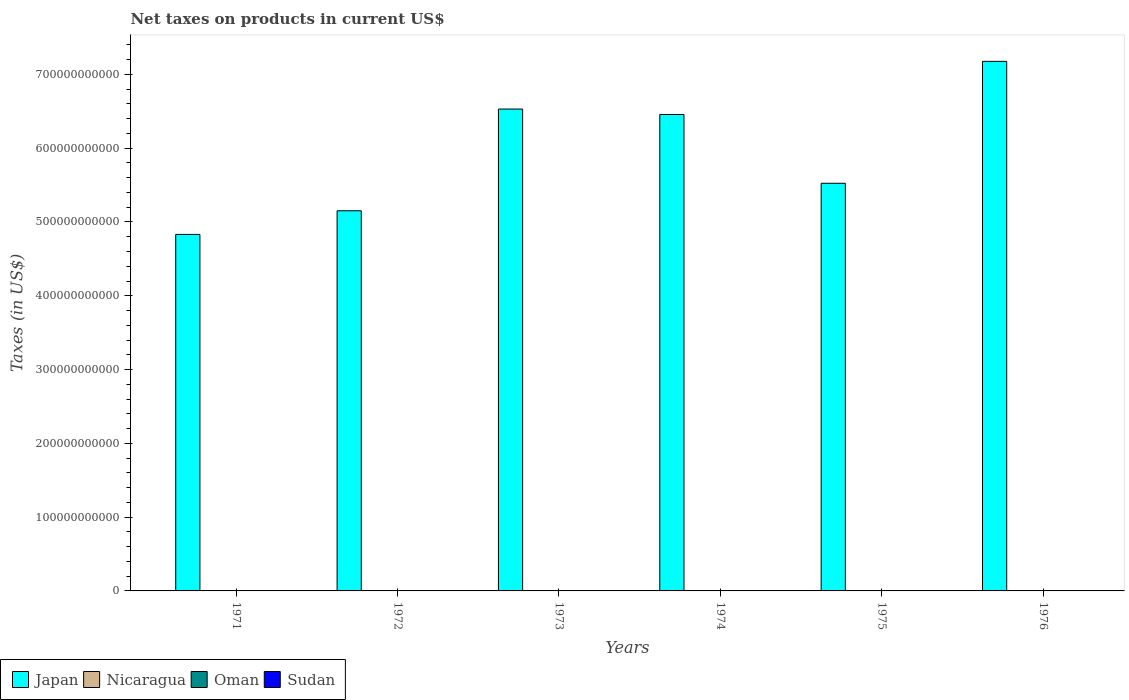How many groups of bars are there?
Provide a short and direct response. 6. Are the number of bars per tick equal to the number of legend labels?
Your answer should be very brief. Yes. How many bars are there on the 6th tick from the left?
Offer a very short reply. 4. How many bars are there on the 6th tick from the right?
Ensure brevity in your answer.  4. What is the label of the 4th group of bars from the left?
Offer a very short reply. 1974. In how many cases, is the number of bars for a given year not equal to the number of legend labels?
Your answer should be compact. 0. What is the net taxes on products in Nicaragua in 1975?
Provide a short and direct response. 0.17. Across all years, what is the maximum net taxes on products in Oman?
Your answer should be very brief. 4.50e+06. Across all years, what is the minimum net taxes on products in Oman?
Your response must be concise. 5.00e+05. In which year was the net taxes on products in Oman maximum?
Offer a very short reply. 1976. What is the total net taxes on products in Japan in the graph?
Provide a short and direct response. 3.57e+12. What is the difference between the net taxes on products in Nicaragua in 1972 and that in 1976?
Your response must be concise. -0.17. What is the difference between the net taxes on products in Sudan in 1975 and the net taxes on products in Nicaragua in 1974?
Your answer should be compact. 1.97e+05. What is the average net taxes on products in Sudan per year?
Make the answer very short. 1.54e+05. In the year 1971, what is the difference between the net taxes on products in Oman and net taxes on products in Nicaragua?
Provide a succinct answer. 1.10e+06. In how many years, is the net taxes on products in Oman greater than 100000000000 US$?
Make the answer very short. 0. What is the ratio of the net taxes on products in Oman in 1972 to that in 1974?
Keep it short and to the point. 0.7. Is the net taxes on products in Oman in 1973 less than that in 1976?
Give a very brief answer. Yes. Is the difference between the net taxes on products in Oman in 1971 and 1975 greater than the difference between the net taxes on products in Nicaragua in 1971 and 1975?
Offer a terse response. Yes. What is the difference between the highest and the second highest net taxes on products in Nicaragua?
Keep it short and to the point. 0.09. What is the difference between the highest and the lowest net taxes on products in Nicaragua?
Make the answer very short. 0.19. Is the sum of the net taxes on products in Japan in 1972 and 1975 greater than the maximum net taxes on products in Oman across all years?
Keep it short and to the point. Yes. Is it the case that in every year, the sum of the net taxes on products in Sudan and net taxes on products in Nicaragua is greater than the sum of net taxes on products in Oman and net taxes on products in Japan?
Offer a very short reply. Yes. What does the 3rd bar from the left in 1973 represents?
Your answer should be very brief. Oman. What does the 2nd bar from the right in 1975 represents?
Make the answer very short. Oman. How many years are there in the graph?
Provide a short and direct response. 6. What is the difference between two consecutive major ticks on the Y-axis?
Keep it short and to the point. 1.00e+11. Where does the legend appear in the graph?
Your response must be concise. Bottom left. How many legend labels are there?
Offer a very short reply. 4. What is the title of the graph?
Provide a succinct answer. Net taxes on products in current US$. What is the label or title of the X-axis?
Make the answer very short. Years. What is the label or title of the Y-axis?
Your response must be concise. Taxes (in US$). What is the Taxes (in US$) of Japan in 1971?
Give a very brief answer. 4.83e+11. What is the Taxes (in US$) in Nicaragua in 1971?
Make the answer very short. 0.07. What is the Taxes (in US$) in Oman in 1971?
Keep it short and to the point. 1.10e+06. What is the Taxes (in US$) in Sudan in 1971?
Provide a short and direct response. 1.03e+05. What is the Taxes (in US$) of Japan in 1972?
Ensure brevity in your answer.  5.15e+11. What is the Taxes (in US$) in Nicaragua in 1972?
Offer a terse response. 0.09. What is the Taxes (in US$) in Oman in 1972?
Your answer should be compact. 1.60e+06. What is the Taxes (in US$) in Sudan in 1972?
Provide a succinct answer. 1.10e+05. What is the Taxes (in US$) of Japan in 1973?
Your answer should be compact. 6.53e+11. What is the Taxes (in US$) in Nicaragua in 1973?
Provide a succinct answer. 0.12. What is the Taxes (in US$) of Oman in 1973?
Your answer should be very brief. 1.70e+06. What is the Taxes (in US$) of Sudan in 1973?
Offer a very short reply. 1.20e+05. What is the Taxes (in US$) in Japan in 1974?
Keep it short and to the point. 6.46e+11. What is the Taxes (in US$) in Nicaragua in 1974?
Keep it short and to the point. 0.15. What is the Taxes (in US$) in Oman in 1974?
Ensure brevity in your answer.  2.30e+06. What is the Taxes (in US$) in Sudan in 1974?
Offer a very short reply. 1.50e+05. What is the Taxes (in US$) in Japan in 1975?
Ensure brevity in your answer.  5.52e+11. What is the Taxes (in US$) in Nicaragua in 1975?
Your response must be concise. 0.17. What is the Taxes (in US$) of Sudan in 1975?
Provide a short and direct response. 1.97e+05. What is the Taxes (in US$) of Japan in 1976?
Offer a terse response. 7.18e+11. What is the Taxes (in US$) of Nicaragua in 1976?
Provide a short and direct response. 0.26. What is the Taxes (in US$) of Oman in 1976?
Your response must be concise. 4.50e+06. What is the Taxes (in US$) of Sudan in 1976?
Provide a succinct answer. 2.41e+05. Across all years, what is the maximum Taxes (in US$) of Japan?
Provide a short and direct response. 7.18e+11. Across all years, what is the maximum Taxes (in US$) in Nicaragua?
Ensure brevity in your answer.  0.26. Across all years, what is the maximum Taxes (in US$) in Oman?
Provide a succinct answer. 4.50e+06. Across all years, what is the maximum Taxes (in US$) of Sudan?
Ensure brevity in your answer.  2.41e+05. Across all years, what is the minimum Taxes (in US$) in Japan?
Your response must be concise. 4.83e+11. Across all years, what is the minimum Taxes (in US$) of Nicaragua?
Your answer should be very brief. 0.07. Across all years, what is the minimum Taxes (in US$) of Sudan?
Your answer should be compact. 1.03e+05. What is the total Taxes (in US$) of Japan in the graph?
Make the answer very short. 3.57e+12. What is the total Taxes (in US$) in Nicaragua in the graph?
Make the answer very short. 0.86. What is the total Taxes (in US$) of Oman in the graph?
Your answer should be very brief. 1.17e+07. What is the total Taxes (in US$) of Sudan in the graph?
Your response must be concise. 9.21e+05. What is the difference between the Taxes (in US$) in Japan in 1971 and that in 1972?
Provide a succinct answer. -3.20e+1. What is the difference between the Taxes (in US$) in Nicaragua in 1971 and that in 1972?
Offer a very short reply. -0.03. What is the difference between the Taxes (in US$) in Oman in 1971 and that in 1972?
Provide a short and direct response. -5.00e+05. What is the difference between the Taxes (in US$) in Sudan in 1971 and that in 1972?
Your response must be concise. -7300. What is the difference between the Taxes (in US$) in Japan in 1971 and that in 1973?
Ensure brevity in your answer.  -1.70e+11. What is the difference between the Taxes (in US$) in Nicaragua in 1971 and that in 1973?
Offer a terse response. -0.06. What is the difference between the Taxes (in US$) of Oman in 1971 and that in 1973?
Make the answer very short. -6.00e+05. What is the difference between the Taxes (in US$) in Sudan in 1971 and that in 1973?
Keep it short and to the point. -1.75e+04. What is the difference between the Taxes (in US$) in Japan in 1971 and that in 1974?
Offer a terse response. -1.63e+11. What is the difference between the Taxes (in US$) of Nicaragua in 1971 and that in 1974?
Provide a short and direct response. -0.08. What is the difference between the Taxes (in US$) of Oman in 1971 and that in 1974?
Make the answer very short. -1.20e+06. What is the difference between the Taxes (in US$) in Sudan in 1971 and that in 1974?
Make the answer very short. -4.67e+04. What is the difference between the Taxes (in US$) of Japan in 1971 and that in 1975?
Keep it short and to the point. -6.93e+1. What is the difference between the Taxes (in US$) of Nicaragua in 1971 and that in 1975?
Your answer should be compact. -0.1. What is the difference between the Taxes (in US$) of Oman in 1971 and that in 1975?
Offer a very short reply. 6.00e+05. What is the difference between the Taxes (in US$) in Sudan in 1971 and that in 1975?
Make the answer very short. -9.43e+04. What is the difference between the Taxes (in US$) of Japan in 1971 and that in 1976?
Ensure brevity in your answer.  -2.35e+11. What is the difference between the Taxes (in US$) in Nicaragua in 1971 and that in 1976?
Keep it short and to the point. -0.19. What is the difference between the Taxes (in US$) of Oman in 1971 and that in 1976?
Ensure brevity in your answer.  -3.40e+06. What is the difference between the Taxes (in US$) in Sudan in 1971 and that in 1976?
Offer a very short reply. -1.38e+05. What is the difference between the Taxes (in US$) in Japan in 1972 and that in 1973?
Offer a very short reply. -1.38e+11. What is the difference between the Taxes (in US$) in Nicaragua in 1972 and that in 1973?
Provide a succinct answer. -0.03. What is the difference between the Taxes (in US$) of Sudan in 1972 and that in 1973?
Your response must be concise. -1.02e+04. What is the difference between the Taxes (in US$) in Japan in 1972 and that in 1974?
Offer a terse response. -1.30e+11. What is the difference between the Taxes (in US$) in Nicaragua in 1972 and that in 1974?
Your response must be concise. -0.06. What is the difference between the Taxes (in US$) of Oman in 1972 and that in 1974?
Give a very brief answer. -7.00e+05. What is the difference between the Taxes (in US$) of Sudan in 1972 and that in 1974?
Your answer should be compact. -3.94e+04. What is the difference between the Taxes (in US$) of Japan in 1972 and that in 1975?
Make the answer very short. -3.73e+1. What is the difference between the Taxes (in US$) in Nicaragua in 1972 and that in 1975?
Offer a terse response. -0.07. What is the difference between the Taxes (in US$) of Oman in 1972 and that in 1975?
Your answer should be very brief. 1.10e+06. What is the difference between the Taxes (in US$) in Sudan in 1972 and that in 1975?
Make the answer very short. -8.70e+04. What is the difference between the Taxes (in US$) of Japan in 1972 and that in 1976?
Keep it short and to the point. -2.02e+11. What is the difference between the Taxes (in US$) of Nicaragua in 1972 and that in 1976?
Your answer should be very brief. -0.17. What is the difference between the Taxes (in US$) of Oman in 1972 and that in 1976?
Offer a terse response. -2.90e+06. What is the difference between the Taxes (in US$) in Sudan in 1972 and that in 1976?
Give a very brief answer. -1.30e+05. What is the difference between the Taxes (in US$) of Japan in 1973 and that in 1974?
Offer a very short reply. 7.37e+09. What is the difference between the Taxes (in US$) in Nicaragua in 1973 and that in 1974?
Your answer should be very brief. -0.03. What is the difference between the Taxes (in US$) in Oman in 1973 and that in 1974?
Give a very brief answer. -6.00e+05. What is the difference between the Taxes (in US$) of Sudan in 1973 and that in 1974?
Give a very brief answer. -2.92e+04. What is the difference between the Taxes (in US$) of Japan in 1973 and that in 1975?
Provide a short and direct response. 1.01e+11. What is the difference between the Taxes (in US$) in Nicaragua in 1973 and that in 1975?
Your answer should be compact. -0.05. What is the difference between the Taxes (in US$) in Oman in 1973 and that in 1975?
Your answer should be very brief. 1.20e+06. What is the difference between the Taxes (in US$) of Sudan in 1973 and that in 1975?
Provide a succinct answer. -7.68e+04. What is the difference between the Taxes (in US$) of Japan in 1973 and that in 1976?
Keep it short and to the point. -6.46e+1. What is the difference between the Taxes (in US$) of Nicaragua in 1973 and that in 1976?
Your response must be concise. -0.14. What is the difference between the Taxes (in US$) in Oman in 1973 and that in 1976?
Keep it short and to the point. -2.80e+06. What is the difference between the Taxes (in US$) of Sudan in 1973 and that in 1976?
Keep it short and to the point. -1.20e+05. What is the difference between the Taxes (in US$) of Japan in 1974 and that in 1975?
Offer a very short reply. 9.32e+1. What is the difference between the Taxes (in US$) of Nicaragua in 1974 and that in 1975?
Ensure brevity in your answer.  -0.02. What is the difference between the Taxes (in US$) of Oman in 1974 and that in 1975?
Give a very brief answer. 1.80e+06. What is the difference between the Taxes (in US$) in Sudan in 1974 and that in 1975?
Offer a very short reply. -4.76e+04. What is the difference between the Taxes (in US$) in Japan in 1974 and that in 1976?
Provide a short and direct response. -7.20e+1. What is the difference between the Taxes (in US$) of Nicaragua in 1974 and that in 1976?
Your answer should be very brief. -0.11. What is the difference between the Taxes (in US$) of Oman in 1974 and that in 1976?
Your answer should be compact. -2.20e+06. What is the difference between the Taxes (in US$) in Sudan in 1974 and that in 1976?
Offer a terse response. -9.11e+04. What is the difference between the Taxes (in US$) of Japan in 1975 and that in 1976?
Offer a very short reply. -1.65e+11. What is the difference between the Taxes (in US$) of Nicaragua in 1975 and that in 1976?
Your response must be concise. -0.09. What is the difference between the Taxes (in US$) of Sudan in 1975 and that in 1976?
Provide a short and direct response. -4.35e+04. What is the difference between the Taxes (in US$) in Japan in 1971 and the Taxes (in US$) in Nicaragua in 1972?
Offer a very short reply. 4.83e+11. What is the difference between the Taxes (in US$) in Japan in 1971 and the Taxes (in US$) in Oman in 1972?
Make the answer very short. 4.83e+11. What is the difference between the Taxes (in US$) in Japan in 1971 and the Taxes (in US$) in Sudan in 1972?
Give a very brief answer. 4.83e+11. What is the difference between the Taxes (in US$) in Nicaragua in 1971 and the Taxes (in US$) in Oman in 1972?
Provide a short and direct response. -1.60e+06. What is the difference between the Taxes (in US$) of Nicaragua in 1971 and the Taxes (in US$) of Sudan in 1972?
Your answer should be very brief. -1.10e+05. What is the difference between the Taxes (in US$) in Oman in 1971 and the Taxes (in US$) in Sudan in 1972?
Provide a short and direct response. 9.90e+05. What is the difference between the Taxes (in US$) in Japan in 1971 and the Taxes (in US$) in Nicaragua in 1973?
Give a very brief answer. 4.83e+11. What is the difference between the Taxes (in US$) in Japan in 1971 and the Taxes (in US$) in Oman in 1973?
Ensure brevity in your answer.  4.83e+11. What is the difference between the Taxes (in US$) of Japan in 1971 and the Taxes (in US$) of Sudan in 1973?
Give a very brief answer. 4.83e+11. What is the difference between the Taxes (in US$) in Nicaragua in 1971 and the Taxes (in US$) in Oman in 1973?
Provide a succinct answer. -1.70e+06. What is the difference between the Taxes (in US$) of Nicaragua in 1971 and the Taxes (in US$) of Sudan in 1973?
Offer a very short reply. -1.20e+05. What is the difference between the Taxes (in US$) in Oman in 1971 and the Taxes (in US$) in Sudan in 1973?
Make the answer very short. 9.80e+05. What is the difference between the Taxes (in US$) in Japan in 1971 and the Taxes (in US$) in Nicaragua in 1974?
Offer a very short reply. 4.83e+11. What is the difference between the Taxes (in US$) in Japan in 1971 and the Taxes (in US$) in Oman in 1974?
Ensure brevity in your answer.  4.83e+11. What is the difference between the Taxes (in US$) in Japan in 1971 and the Taxes (in US$) in Sudan in 1974?
Make the answer very short. 4.83e+11. What is the difference between the Taxes (in US$) in Nicaragua in 1971 and the Taxes (in US$) in Oman in 1974?
Provide a succinct answer. -2.30e+06. What is the difference between the Taxes (in US$) of Nicaragua in 1971 and the Taxes (in US$) of Sudan in 1974?
Give a very brief answer. -1.50e+05. What is the difference between the Taxes (in US$) in Oman in 1971 and the Taxes (in US$) in Sudan in 1974?
Provide a short and direct response. 9.50e+05. What is the difference between the Taxes (in US$) of Japan in 1971 and the Taxes (in US$) of Nicaragua in 1975?
Keep it short and to the point. 4.83e+11. What is the difference between the Taxes (in US$) of Japan in 1971 and the Taxes (in US$) of Oman in 1975?
Your response must be concise. 4.83e+11. What is the difference between the Taxes (in US$) of Japan in 1971 and the Taxes (in US$) of Sudan in 1975?
Give a very brief answer. 4.83e+11. What is the difference between the Taxes (in US$) in Nicaragua in 1971 and the Taxes (in US$) in Oman in 1975?
Provide a short and direct response. -5.00e+05. What is the difference between the Taxes (in US$) in Nicaragua in 1971 and the Taxes (in US$) in Sudan in 1975?
Give a very brief answer. -1.97e+05. What is the difference between the Taxes (in US$) in Oman in 1971 and the Taxes (in US$) in Sudan in 1975?
Your answer should be compact. 9.03e+05. What is the difference between the Taxes (in US$) in Japan in 1971 and the Taxes (in US$) in Nicaragua in 1976?
Your answer should be very brief. 4.83e+11. What is the difference between the Taxes (in US$) of Japan in 1971 and the Taxes (in US$) of Oman in 1976?
Ensure brevity in your answer.  4.83e+11. What is the difference between the Taxes (in US$) in Japan in 1971 and the Taxes (in US$) in Sudan in 1976?
Make the answer very short. 4.83e+11. What is the difference between the Taxes (in US$) of Nicaragua in 1971 and the Taxes (in US$) of Oman in 1976?
Your answer should be compact. -4.50e+06. What is the difference between the Taxes (in US$) in Nicaragua in 1971 and the Taxes (in US$) in Sudan in 1976?
Ensure brevity in your answer.  -2.41e+05. What is the difference between the Taxes (in US$) of Oman in 1971 and the Taxes (in US$) of Sudan in 1976?
Ensure brevity in your answer.  8.59e+05. What is the difference between the Taxes (in US$) of Japan in 1972 and the Taxes (in US$) of Nicaragua in 1973?
Your response must be concise. 5.15e+11. What is the difference between the Taxes (in US$) in Japan in 1972 and the Taxes (in US$) in Oman in 1973?
Offer a very short reply. 5.15e+11. What is the difference between the Taxes (in US$) of Japan in 1972 and the Taxes (in US$) of Sudan in 1973?
Offer a terse response. 5.15e+11. What is the difference between the Taxes (in US$) of Nicaragua in 1972 and the Taxes (in US$) of Oman in 1973?
Provide a short and direct response. -1.70e+06. What is the difference between the Taxes (in US$) of Nicaragua in 1972 and the Taxes (in US$) of Sudan in 1973?
Your response must be concise. -1.20e+05. What is the difference between the Taxes (in US$) of Oman in 1972 and the Taxes (in US$) of Sudan in 1973?
Make the answer very short. 1.48e+06. What is the difference between the Taxes (in US$) in Japan in 1972 and the Taxes (in US$) in Nicaragua in 1974?
Provide a short and direct response. 5.15e+11. What is the difference between the Taxes (in US$) in Japan in 1972 and the Taxes (in US$) in Oman in 1974?
Give a very brief answer. 5.15e+11. What is the difference between the Taxes (in US$) in Japan in 1972 and the Taxes (in US$) in Sudan in 1974?
Make the answer very short. 5.15e+11. What is the difference between the Taxes (in US$) of Nicaragua in 1972 and the Taxes (in US$) of Oman in 1974?
Keep it short and to the point. -2.30e+06. What is the difference between the Taxes (in US$) of Nicaragua in 1972 and the Taxes (in US$) of Sudan in 1974?
Offer a very short reply. -1.50e+05. What is the difference between the Taxes (in US$) in Oman in 1972 and the Taxes (in US$) in Sudan in 1974?
Provide a succinct answer. 1.45e+06. What is the difference between the Taxes (in US$) of Japan in 1972 and the Taxes (in US$) of Nicaragua in 1975?
Ensure brevity in your answer.  5.15e+11. What is the difference between the Taxes (in US$) of Japan in 1972 and the Taxes (in US$) of Oman in 1975?
Your response must be concise. 5.15e+11. What is the difference between the Taxes (in US$) of Japan in 1972 and the Taxes (in US$) of Sudan in 1975?
Provide a short and direct response. 5.15e+11. What is the difference between the Taxes (in US$) of Nicaragua in 1972 and the Taxes (in US$) of Oman in 1975?
Offer a terse response. -5.00e+05. What is the difference between the Taxes (in US$) in Nicaragua in 1972 and the Taxes (in US$) in Sudan in 1975?
Your response must be concise. -1.97e+05. What is the difference between the Taxes (in US$) in Oman in 1972 and the Taxes (in US$) in Sudan in 1975?
Make the answer very short. 1.40e+06. What is the difference between the Taxes (in US$) in Japan in 1972 and the Taxes (in US$) in Nicaragua in 1976?
Provide a short and direct response. 5.15e+11. What is the difference between the Taxes (in US$) of Japan in 1972 and the Taxes (in US$) of Oman in 1976?
Provide a succinct answer. 5.15e+11. What is the difference between the Taxes (in US$) in Japan in 1972 and the Taxes (in US$) in Sudan in 1976?
Provide a short and direct response. 5.15e+11. What is the difference between the Taxes (in US$) in Nicaragua in 1972 and the Taxes (in US$) in Oman in 1976?
Your answer should be compact. -4.50e+06. What is the difference between the Taxes (in US$) of Nicaragua in 1972 and the Taxes (in US$) of Sudan in 1976?
Keep it short and to the point. -2.41e+05. What is the difference between the Taxes (in US$) in Oman in 1972 and the Taxes (in US$) in Sudan in 1976?
Give a very brief answer. 1.36e+06. What is the difference between the Taxes (in US$) in Japan in 1973 and the Taxes (in US$) in Nicaragua in 1974?
Offer a terse response. 6.53e+11. What is the difference between the Taxes (in US$) in Japan in 1973 and the Taxes (in US$) in Oman in 1974?
Provide a succinct answer. 6.53e+11. What is the difference between the Taxes (in US$) in Japan in 1973 and the Taxes (in US$) in Sudan in 1974?
Your response must be concise. 6.53e+11. What is the difference between the Taxes (in US$) of Nicaragua in 1973 and the Taxes (in US$) of Oman in 1974?
Your answer should be very brief. -2.30e+06. What is the difference between the Taxes (in US$) in Nicaragua in 1973 and the Taxes (in US$) in Sudan in 1974?
Offer a terse response. -1.50e+05. What is the difference between the Taxes (in US$) in Oman in 1973 and the Taxes (in US$) in Sudan in 1974?
Your answer should be compact. 1.55e+06. What is the difference between the Taxes (in US$) of Japan in 1973 and the Taxes (in US$) of Nicaragua in 1975?
Give a very brief answer. 6.53e+11. What is the difference between the Taxes (in US$) of Japan in 1973 and the Taxes (in US$) of Oman in 1975?
Keep it short and to the point. 6.53e+11. What is the difference between the Taxes (in US$) of Japan in 1973 and the Taxes (in US$) of Sudan in 1975?
Your response must be concise. 6.53e+11. What is the difference between the Taxes (in US$) in Nicaragua in 1973 and the Taxes (in US$) in Oman in 1975?
Keep it short and to the point. -5.00e+05. What is the difference between the Taxes (in US$) in Nicaragua in 1973 and the Taxes (in US$) in Sudan in 1975?
Keep it short and to the point. -1.97e+05. What is the difference between the Taxes (in US$) in Oman in 1973 and the Taxes (in US$) in Sudan in 1975?
Keep it short and to the point. 1.50e+06. What is the difference between the Taxes (in US$) of Japan in 1973 and the Taxes (in US$) of Nicaragua in 1976?
Your answer should be very brief. 6.53e+11. What is the difference between the Taxes (in US$) in Japan in 1973 and the Taxes (in US$) in Oman in 1976?
Make the answer very short. 6.53e+11. What is the difference between the Taxes (in US$) of Japan in 1973 and the Taxes (in US$) of Sudan in 1976?
Provide a short and direct response. 6.53e+11. What is the difference between the Taxes (in US$) of Nicaragua in 1973 and the Taxes (in US$) of Oman in 1976?
Provide a succinct answer. -4.50e+06. What is the difference between the Taxes (in US$) in Nicaragua in 1973 and the Taxes (in US$) in Sudan in 1976?
Offer a very short reply. -2.41e+05. What is the difference between the Taxes (in US$) in Oman in 1973 and the Taxes (in US$) in Sudan in 1976?
Your answer should be very brief. 1.46e+06. What is the difference between the Taxes (in US$) of Japan in 1974 and the Taxes (in US$) of Nicaragua in 1975?
Give a very brief answer. 6.46e+11. What is the difference between the Taxes (in US$) in Japan in 1974 and the Taxes (in US$) in Oman in 1975?
Ensure brevity in your answer.  6.46e+11. What is the difference between the Taxes (in US$) in Japan in 1974 and the Taxes (in US$) in Sudan in 1975?
Offer a terse response. 6.46e+11. What is the difference between the Taxes (in US$) in Nicaragua in 1974 and the Taxes (in US$) in Oman in 1975?
Offer a very short reply. -5.00e+05. What is the difference between the Taxes (in US$) in Nicaragua in 1974 and the Taxes (in US$) in Sudan in 1975?
Offer a terse response. -1.97e+05. What is the difference between the Taxes (in US$) in Oman in 1974 and the Taxes (in US$) in Sudan in 1975?
Make the answer very short. 2.10e+06. What is the difference between the Taxes (in US$) of Japan in 1974 and the Taxes (in US$) of Nicaragua in 1976?
Your answer should be very brief. 6.46e+11. What is the difference between the Taxes (in US$) of Japan in 1974 and the Taxes (in US$) of Oman in 1976?
Provide a succinct answer. 6.46e+11. What is the difference between the Taxes (in US$) of Japan in 1974 and the Taxes (in US$) of Sudan in 1976?
Offer a very short reply. 6.46e+11. What is the difference between the Taxes (in US$) in Nicaragua in 1974 and the Taxes (in US$) in Oman in 1976?
Offer a terse response. -4.50e+06. What is the difference between the Taxes (in US$) in Nicaragua in 1974 and the Taxes (in US$) in Sudan in 1976?
Provide a succinct answer. -2.41e+05. What is the difference between the Taxes (in US$) of Oman in 1974 and the Taxes (in US$) of Sudan in 1976?
Keep it short and to the point. 2.06e+06. What is the difference between the Taxes (in US$) in Japan in 1975 and the Taxes (in US$) in Nicaragua in 1976?
Keep it short and to the point. 5.52e+11. What is the difference between the Taxes (in US$) of Japan in 1975 and the Taxes (in US$) of Oman in 1976?
Provide a short and direct response. 5.52e+11. What is the difference between the Taxes (in US$) of Japan in 1975 and the Taxes (in US$) of Sudan in 1976?
Provide a short and direct response. 5.52e+11. What is the difference between the Taxes (in US$) in Nicaragua in 1975 and the Taxes (in US$) in Oman in 1976?
Offer a very short reply. -4.50e+06. What is the difference between the Taxes (in US$) of Nicaragua in 1975 and the Taxes (in US$) of Sudan in 1976?
Your response must be concise. -2.41e+05. What is the difference between the Taxes (in US$) of Oman in 1975 and the Taxes (in US$) of Sudan in 1976?
Offer a very short reply. 2.59e+05. What is the average Taxes (in US$) of Japan per year?
Keep it short and to the point. 5.95e+11. What is the average Taxes (in US$) of Nicaragua per year?
Offer a terse response. 0.14. What is the average Taxes (in US$) of Oman per year?
Offer a very short reply. 1.95e+06. What is the average Taxes (in US$) in Sudan per year?
Ensure brevity in your answer.  1.54e+05. In the year 1971, what is the difference between the Taxes (in US$) in Japan and Taxes (in US$) in Nicaragua?
Provide a short and direct response. 4.83e+11. In the year 1971, what is the difference between the Taxes (in US$) of Japan and Taxes (in US$) of Oman?
Provide a short and direct response. 4.83e+11. In the year 1971, what is the difference between the Taxes (in US$) of Japan and Taxes (in US$) of Sudan?
Your answer should be compact. 4.83e+11. In the year 1971, what is the difference between the Taxes (in US$) in Nicaragua and Taxes (in US$) in Oman?
Your answer should be compact. -1.10e+06. In the year 1971, what is the difference between the Taxes (in US$) in Nicaragua and Taxes (in US$) in Sudan?
Give a very brief answer. -1.03e+05. In the year 1971, what is the difference between the Taxes (in US$) of Oman and Taxes (in US$) of Sudan?
Your answer should be compact. 9.97e+05. In the year 1972, what is the difference between the Taxes (in US$) in Japan and Taxes (in US$) in Nicaragua?
Your response must be concise. 5.15e+11. In the year 1972, what is the difference between the Taxes (in US$) in Japan and Taxes (in US$) in Oman?
Give a very brief answer. 5.15e+11. In the year 1972, what is the difference between the Taxes (in US$) in Japan and Taxes (in US$) in Sudan?
Your response must be concise. 5.15e+11. In the year 1972, what is the difference between the Taxes (in US$) in Nicaragua and Taxes (in US$) in Oman?
Ensure brevity in your answer.  -1.60e+06. In the year 1972, what is the difference between the Taxes (in US$) in Nicaragua and Taxes (in US$) in Sudan?
Ensure brevity in your answer.  -1.10e+05. In the year 1972, what is the difference between the Taxes (in US$) of Oman and Taxes (in US$) of Sudan?
Keep it short and to the point. 1.49e+06. In the year 1973, what is the difference between the Taxes (in US$) of Japan and Taxes (in US$) of Nicaragua?
Keep it short and to the point. 6.53e+11. In the year 1973, what is the difference between the Taxes (in US$) of Japan and Taxes (in US$) of Oman?
Offer a very short reply. 6.53e+11. In the year 1973, what is the difference between the Taxes (in US$) of Japan and Taxes (in US$) of Sudan?
Your response must be concise. 6.53e+11. In the year 1973, what is the difference between the Taxes (in US$) of Nicaragua and Taxes (in US$) of Oman?
Provide a succinct answer. -1.70e+06. In the year 1973, what is the difference between the Taxes (in US$) in Nicaragua and Taxes (in US$) in Sudan?
Your response must be concise. -1.20e+05. In the year 1973, what is the difference between the Taxes (in US$) in Oman and Taxes (in US$) in Sudan?
Provide a short and direct response. 1.58e+06. In the year 1974, what is the difference between the Taxes (in US$) of Japan and Taxes (in US$) of Nicaragua?
Offer a very short reply. 6.46e+11. In the year 1974, what is the difference between the Taxes (in US$) of Japan and Taxes (in US$) of Oman?
Make the answer very short. 6.46e+11. In the year 1974, what is the difference between the Taxes (in US$) in Japan and Taxes (in US$) in Sudan?
Provide a succinct answer. 6.46e+11. In the year 1974, what is the difference between the Taxes (in US$) in Nicaragua and Taxes (in US$) in Oman?
Make the answer very short. -2.30e+06. In the year 1974, what is the difference between the Taxes (in US$) of Nicaragua and Taxes (in US$) of Sudan?
Your answer should be compact. -1.50e+05. In the year 1974, what is the difference between the Taxes (in US$) in Oman and Taxes (in US$) in Sudan?
Make the answer very short. 2.15e+06. In the year 1975, what is the difference between the Taxes (in US$) in Japan and Taxes (in US$) in Nicaragua?
Offer a terse response. 5.52e+11. In the year 1975, what is the difference between the Taxes (in US$) in Japan and Taxes (in US$) in Oman?
Your answer should be very brief. 5.52e+11. In the year 1975, what is the difference between the Taxes (in US$) in Japan and Taxes (in US$) in Sudan?
Give a very brief answer. 5.52e+11. In the year 1975, what is the difference between the Taxes (in US$) of Nicaragua and Taxes (in US$) of Oman?
Your answer should be very brief. -5.00e+05. In the year 1975, what is the difference between the Taxes (in US$) of Nicaragua and Taxes (in US$) of Sudan?
Offer a terse response. -1.97e+05. In the year 1975, what is the difference between the Taxes (in US$) in Oman and Taxes (in US$) in Sudan?
Your response must be concise. 3.03e+05. In the year 1976, what is the difference between the Taxes (in US$) in Japan and Taxes (in US$) in Nicaragua?
Give a very brief answer. 7.18e+11. In the year 1976, what is the difference between the Taxes (in US$) of Japan and Taxes (in US$) of Oman?
Offer a very short reply. 7.18e+11. In the year 1976, what is the difference between the Taxes (in US$) of Japan and Taxes (in US$) of Sudan?
Keep it short and to the point. 7.18e+11. In the year 1976, what is the difference between the Taxes (in US$) of Nicaragua and Taxes (in US$) of Oman?
Make the answer very short. -4.50e+06. In the year 1976, what is the difference between the Taxes (in US$) in Nicaragua and Taxes (in US$) in Sudan?
Provide a short and direct response. -2.41e+05. In the year 1976, what is the difference between the Taxes (in US$) in Oman and Taxes (in US$) in Sudan?
Your answer should be compact. 4.26e+06. What is the ratio of the Taxes (in US$) in Japan in 1971 to that in 1972?
Your answer should be compact. 0.94. What is the ratio of the Taxes (in US$) in Nicaragua in 1971 to that in 1972?
Provide a short and direct response. 0.72. What is the ratio of the Taxes (in US$) in Oman in 1971 to that in 1972?
Ensure brevity in your answer.  0.69. What is the ratio of the Taxes (in US$) in Sudan in 1971 to that in 1972?
Your answer should be compact. 0.93. What is the ratio of the Taxes (in US$) of Japan in 1971 to that in 1973?
Keep it short and to the point. 0.74. What is the ratio of the Taxes (in US$) of Nicaragua in 1971 to that in 1973?
Your answer should be compact. 0.54. What is the ratio of the Taxes (in US$) of Oman in 1971 to that in 1973?
Your answer should be compact. 0.65. What is the ratio of the Taxes (in US$) of Sudan in 1971 to that in 1973?
Keep it short and to the point. 0.85. What is the ratio of the Taxes (in US$) of Japan in 1971 to that in 1974?
Ensure brevity in your answer.  0.75. What is the ratio of the Taxes (in US$) of Nicaragua in 1971 to that in 1974?
Your answer should be very brief. 0.44. What is the ratio of the Taxes (in US$) of Oman in 1971 to that in 1974?
Your answer should be very brief. 0.48. What is the ratio of the Taxes (in US$) in Sudan in 1971 to that in 1974?
Keep it short and to the point. 0.69. What is the ratio of the Taxes (in US$) of Japan in 1971 to that in 1975?
Provide a succinct answer. 0.87. What is the ratio of the Taxes (in US$) in Nicaragua in 1971 to that in 1975?
Your answer should be very brief. 0.4. What is the ratio of the Taxes (in US$) in Oman in 1971 to that in 1975?
Give a very brief answer. 2.2. What is the ratio of the Taxes (in US$) in Sudan in 1971 to that in 1975?
Keep it short and to the point. 0.52. What is the ratio of the Taxes (in US$) in Japan in 1971 to that in 1976?
Your response must be concise. 0.67. What is the ratio of the Taxes (in US$) in Nicaragua in 1971 to that in 1976?
Ensure brevity in your answer.  0.25. What is the ratio of the Taxes (in US$) in Oman in 1971 to that in 1976?
Make the answer very short. 0.24. What is the ratio of the Taxes (in US$) of Sudan in 1971 to that in 1976?
Your answer should be compact. 0.43. What is the ratio of the Taxes (in US$) of Japan in 1972 to that in 1973?
Offer a very short reply. 0.79. What is the ratio of the Taxes (in US$) of Nicaragua in 1972 to that in 1973?
Offer a very short reply. 0.76. What is the ratio of the Taxes (in US$) of Sudan in 1972 to that in 1973?
Make the answer very short. 0.92. What is the ratio of the Taxes (in US$) in Japan in 1972 to that in 1974?
Your response must be concise. 0.8. What is the ratio of the Taxes (in US$) of Nicaragua in 1972 to that in 1974?
Offer a terse response. 0.61. What is the ratio of the Taxes (in US$) of Oman in 1972 to that in 1974?
Give a very brief answer. 0.7. What is the ratio of the Taxes (in US$) in Sudan in 1972 to that in 1974?
Provide a succinct answer. 0.74. What is the ratio of the Taxes (in US$) in Japan in 1972 to that in 1975?
Offer a terse response. 0.93. What is the ratio of the Taxes (in US$) of Nicaragua in 1972 to that in 1975?
Offer a terse response. 0.55. What is the ratio of the Taxes (in US$) in Oman in 1972 to that in 1975?
Make the answer very short. 3.2. What is the ratio of the Taxes (in US$) of Sudan in 1972 to that in 1975?
Keep it short and to the point. 0.56. What is the ratio of the Taxes (in US$) in Japan in 1972 to that in 1976?
Ensure brevity in your answer.  0.72. What is the ratio of the Taxes (in US$) of Nicaragua in 1972 to that in 1976?
Make the answer very short. 0.36. What is the ratio of the Taxes (in US$) in Oman in 1972 to that in 1976?
Ensure brevity in your answer.  0.36. What is the ratio of the Taxes (in US$) of Sudan in 1972 to that in 1976?
Your answer should be very brief. 0.46. What is the ratio of the Taxes (in US$) in Japan in 1973 to that in 1974?
Your response must be concise. 1.01. What is the ratio of the Taxes (in US$) of Nicaragua in 1973 to that in 1974?
Offer a very short reply. 0.81. What is the ratio of the Taxes (in US$) of Oman in 1973 to that in 1974?
Provide a short and direct response. 0.74. What is the ratio of the Taxes (in US$) of Sudan in 1973 to that in 1974?
Provide a short and direct response. 0.8. What is the ratio of the Taxes (in US$) in Japan in 1973 to that in 1975?
Your answer should be very brief. 1.18. What is the ratio of the Taxes (in US$) of Nicaragua in 1973 to that in 1975?
Your response must be concise. 0.73. What is the ratio of the Taxes (in US$) in Oman in 1973 to that in 1975?
Keep it short and to the point. 3.4. What is the ratio of the Taxes (in US$) in Sudan in 1973 to that in 1975?
Offer a very short reply. 0.61. What is the ratio of the Taxes (in US$) in Japan in 1973 to that in 1976?
Keep it short and to the point. 0.91. What is the ratio of the Taxes (in US$) in Nicaragua in 1973 to that in 1976?
Offer a very short reply. 0.47. What is the ratio of the Taxes (in US$) in Oman in 1973 to that in 1976?
Keep it short and to the point. 0.38. What is the ratio of the Taxes (in US$) in Sudan in 1973 to that in 1976?
Offer a terse response. 0.5. What is the ratio of the Taxes (in US$) in Japan in 1974 to that in 1975?
Ensure brevity in your answer.  1.17. What is the ratio of the Taxes (in US$) of Nicaragua in 1974 to that in 1975?
Provide a short and direct response. 0.9. What is the ratio of the Taxes (in US$) of Sudan in 1974 to that in 1975?
Your response must be concise. 0.76. What is the ratio of the Taxes (in US$) in Japan in 1974 to that in 1976?
Offer a very short reply. 0.9. What is the ratio of the Taxes (in US$) in Nicaragua in 1974 to that in 1976?
Make the answer very short. 0.58. What is the ratio of the Taxes (in US$) of Oman in 1974 to that in 1976?
Provide a short and direct response. 0.51. What is the ratio of the Taxes (in US$) of Sudan in 1974 to that in 1976?
Your answer should be compact. 0.62. What is the ratio of the Taxes (in US$) in Japan in 1975 to that in 1976?
Offer a terse response. 0.77. What is the ratio of the Taxes (in US$) in Nicaragua in 1975 to that in 1976?
Your response must be concise. 0.64. What is the ratio of the Taxes (in US$) of Sudan in 1975 to that in 1976?
Ensure brevity in your answer.  0.82. What is the difference between the highest and the second highest Taxes (in US$) of Japan?
Your answer should be compact. 6.46e+1. What is the difference between the highest and the second highest Taxes (in US$) in Nicaragua?
Keep it short and to the point. 0.09. What is the difference between the highest and the second highest Taxes (in US$) of Oman?
Provide a succinct answer. 2.20e+06. What is the difference between the highest and the second highest Taxes (in US$) of Sudan?
Your answer should be compact. 4.35e+04. What is the difference between the highest and the lowest Taxes (in US$) in Japan?
Make the answer very short. 2.35e+11. What is the difference between the highest and the lowest Taxes (in US$) of Nicaragua?
Your answer should be very brief. 0.19. What is the difference between the highest and the lowest Taxes (in US$) of Oman?
Keep it short and to the point. 4.00e+06. What is the difference between the highest and the lowest Taxes (in US$) in Sudan?
Your answer should be very brief. 1.38e+05. 